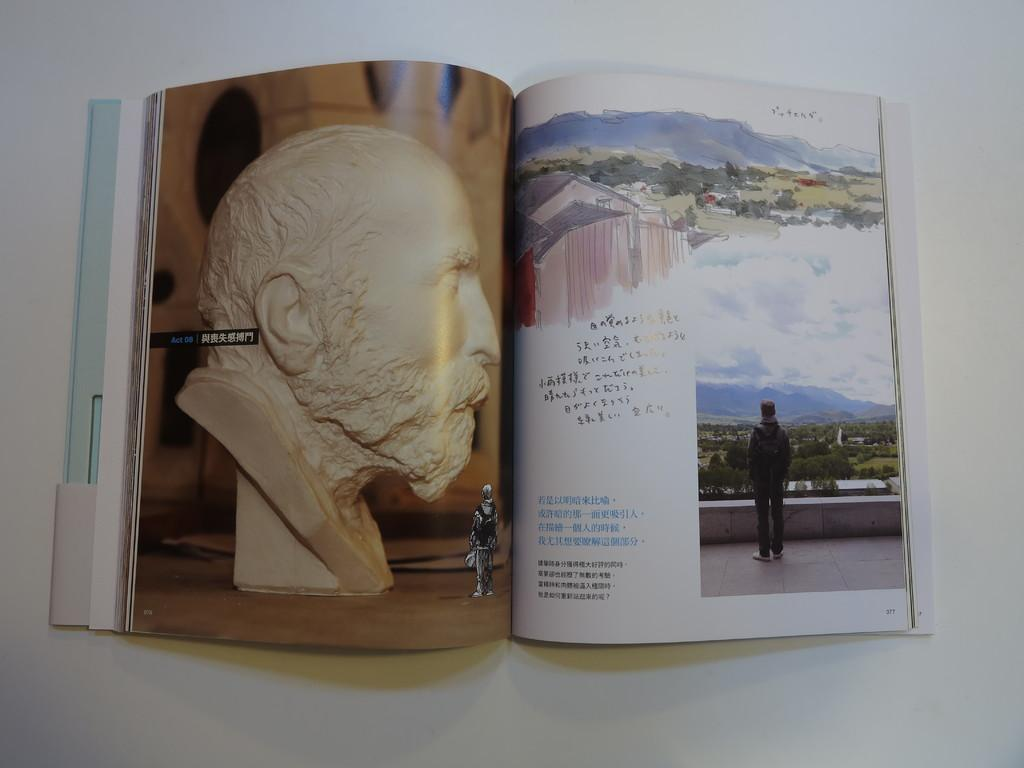<image>
Write a terse but informative summary of the picture. A book has a picture of a plaster head with the word Act to its left. 